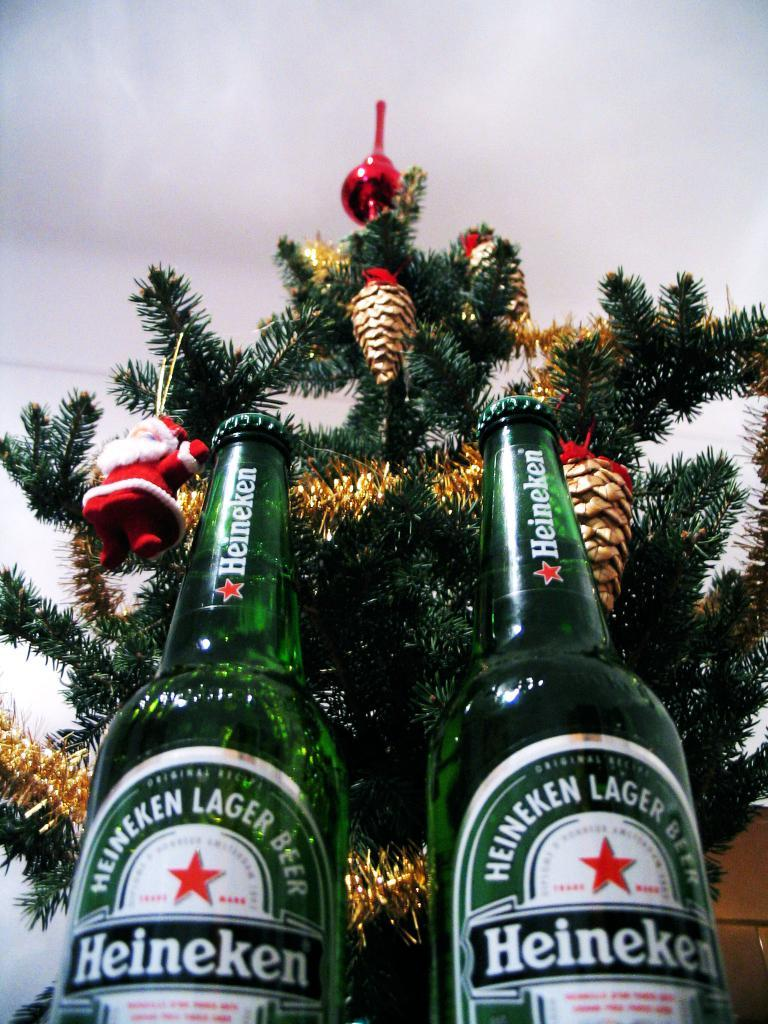What type of beverage containers are visible in the image? There are two beer bottles in the image. What holiday-related object is present in the image? There is a Christmas tree in the image. Where are the beer bottles located in relation to the Christmas tree? The beer bottles are in front of the Christmas tree. Can you see anyone smiling in the image? There is no person present in the image, so it is not possible to determine if anyone is smiling. 